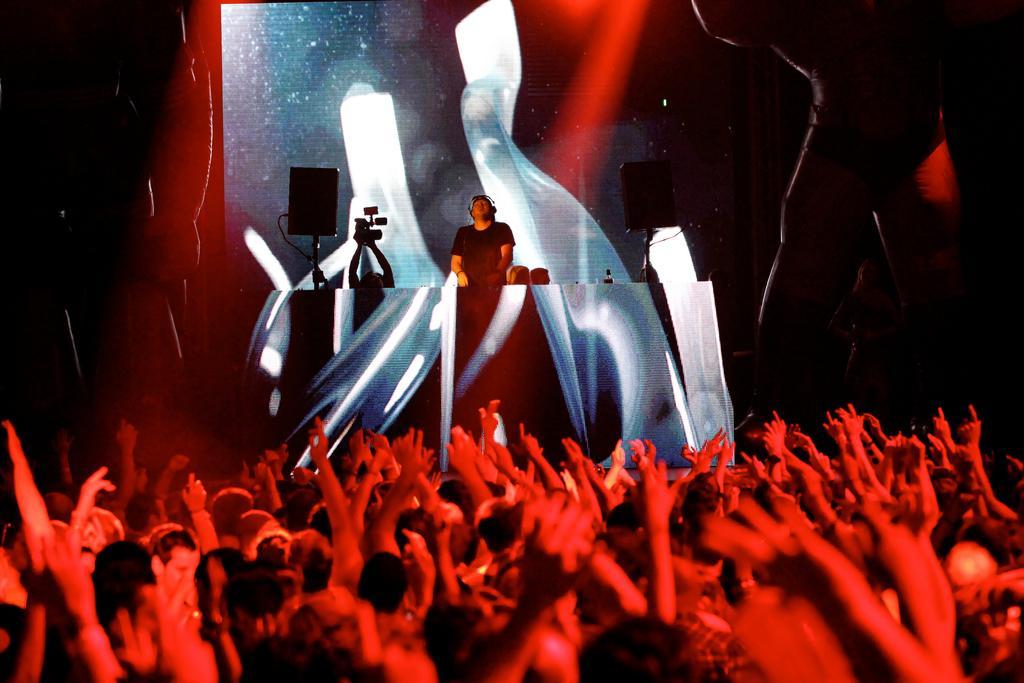Describe this image in one or two sentences. In the image we can see there are many people dancing and they are wearing clothes. There is a person on the stage, wearing clothes and headset. These are the sound boxes and this is a video camera. 